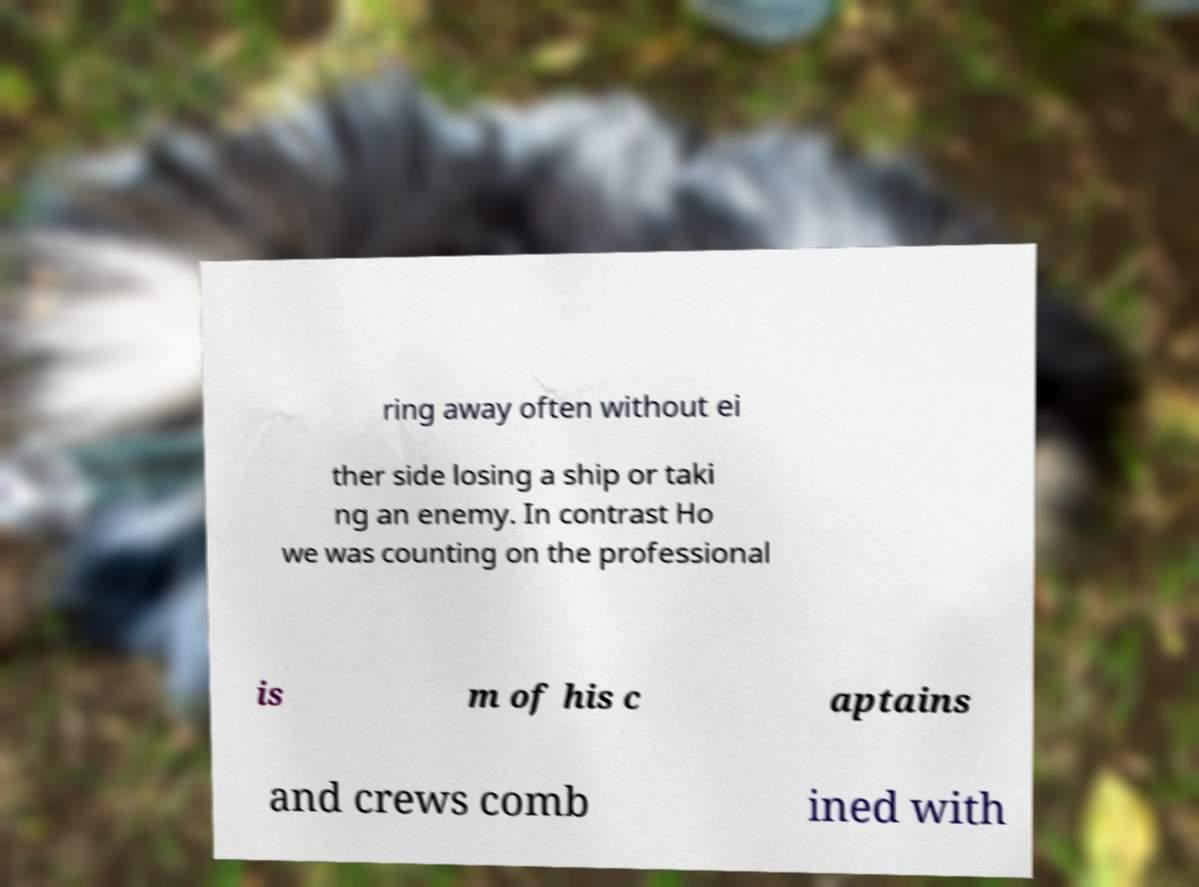Please identify and transcribe the text found in this image. ring away often without ei ther side losing a ship or taki ng an enemy. In contrast Ho we was counting on the professional is m of his c aptains and crews comb ined with 